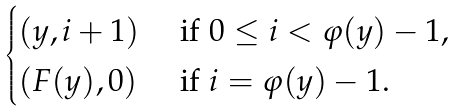Convert formula to latex. <formula><loc_0><loc_0><loc_500><loc_500>\begin{cases} ( y , i + 1 ) & \text { if } 0 \leq i < \varphi ( y ) - 1 , \\ ( F ( y ) , 0 ) & \text { if } i = \varphi ( y ) - 1 . \end{cases}</formula> 